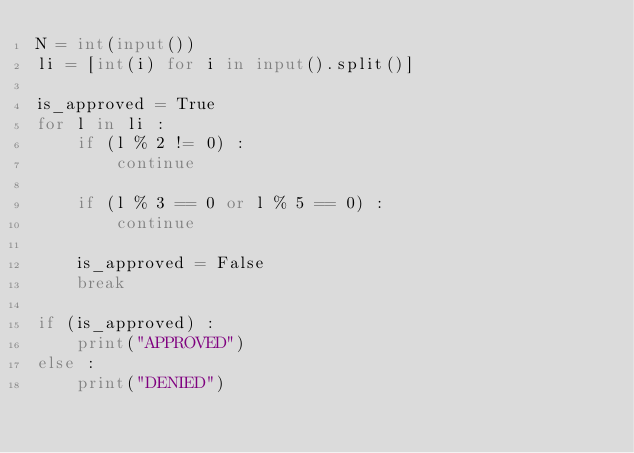Convert code to text. <code><loc_0><loc_0><loc_500><loc_500><_Python_>N = int(input())
li = [int(i) for i in input().split()]

is_approved = True
for l in li :
    if (l % 2 != 0) :
        continue

    if (l % 3 == 0 or l % 5 == 0) :
        continue

    is_approved = False
    break

if (is_approved) :
    print("APPROVED")
else :
    print("DENIED")

</code> 